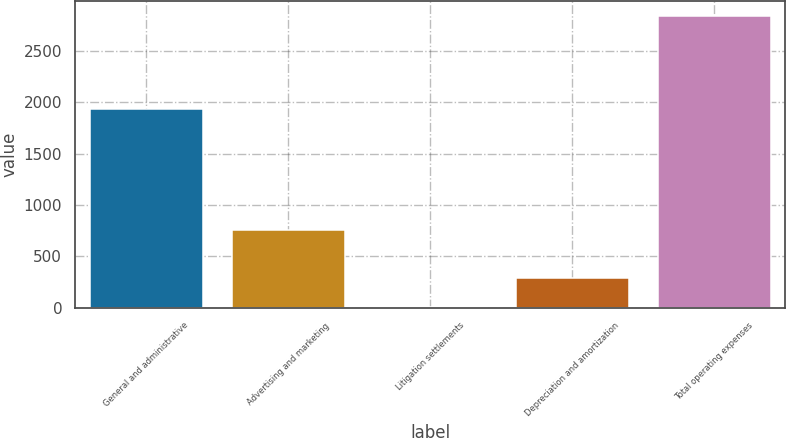Convert chart. <chart><loc_0><loc_0><loc_500><loc_500><bar_chart><fcel>General and administrative<fcel>Advertising and marketing<fcel>Litigation settlements<fcel>Depreciation and amortization<fcel>Total operating expenses<nl><fcel>1935<fcel>756<fcel>7<fcel>290.2<fcel>2839<nl></chart> 